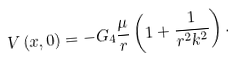Convert formula to latex. <formula><loc_0><loc_0><loc_500><loc_500>V \left ( x , 0 \right ) = - G _ { 4 } \frac { \mu } { r } \left ( 1 + \frac { 1 } { r ^ { 2 } k ^ { 2 } } \right ) .</formula> 